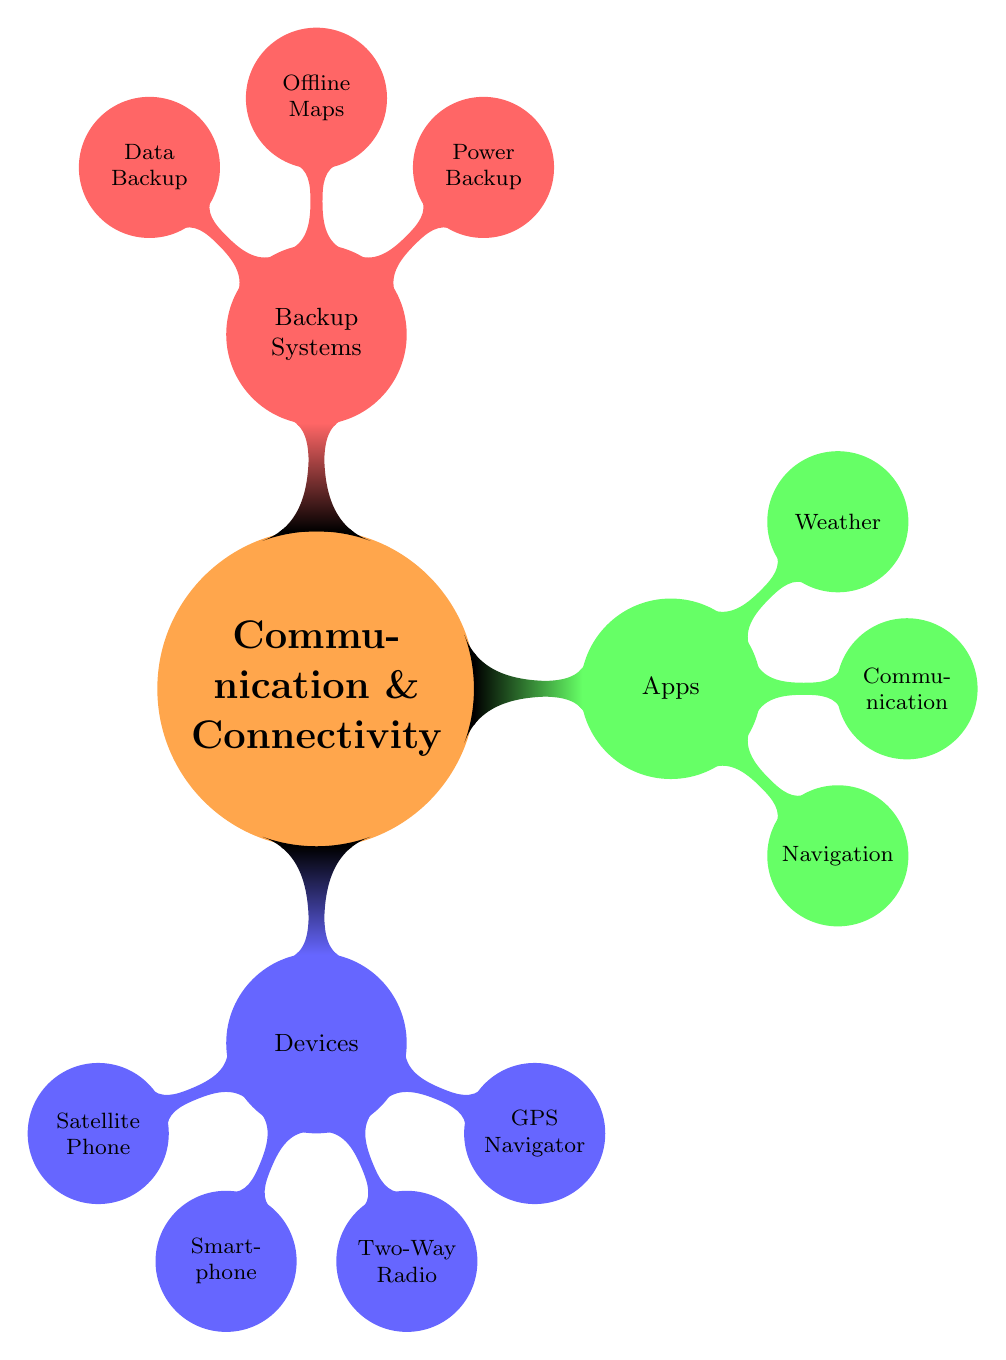What's the total number of devices listed? The diagram provides a list of devices under the "Devices" category. Counting each listed device (Satellite Phone, Smartphone, Two-Way Radio, GPS Navigator), there are a total of 4 devices in this section.
Answer: 4 Which app is categorized under Communication? The diagram shows a branch for "Apps" which includes Navigation, Communication, and Weather. Under the Communication category, “WhatsApp, Zello” is listed.
Answer: WhatsApp, Zello What type of device is the Iridium 9555? The Iridium 9555 is listed under the "Devices" category as a "Satellite Phone". This information helps classify its type within communication devices.
Answer: Satellite Phone How many types of backup systems are mentioned? The diagram includes a section for "Backup Systems." There are three subcategories in this section: Power Backup, Offline Maps, and Data Backup, which contributes to a total of 3 types.
Answer: 3 Which device type is represented by the Garmin dēzl 580? The Garmin dēzl 580 is mentioned under the "Devices" category specifically as a GPS Navigator. This classification is derived from the node's context in the diagram.
Answer: GPS Navigator Which apps are listed for Weather? The Weather category under "Apps" includes AccuWeather and WeatherBug. This is a direct reading from the designated section of the mind map, revealing the specific apps mentioned for this functionality.
Answer: AccuWeather, WeatherBug Is there a backup system for data mentioned? The "Backup Systems" section lists a specific node for “Data Backup,” referring to the SanDisk Extreme Portable SSD. This indicates that a dedicated system for data backup is indeed included.
Answer: Yes What is the primary function of the Anker PowerHouse 200? In the diagram, the Anker PowerHouse 200 is categorized under "Power Backup" in the "Backup Systems" section, indicating its role as a power source.
Answer: Power Backup What types of navigation apps are indicated? The "Apps" section identifies "Navigation" as a category that encompasses Google Maps and Waze, which are explicitly listed. This can be deduced directly from the mentioned nodes under the Navigation category.
Answer: Google Maps, Waze 